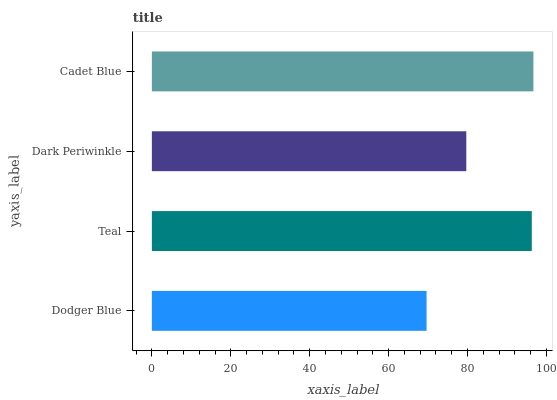Is Dodger Blue the minimum?
Answer yes or no. Yes. Is Cadet Blue the maximum?
Answer yes or no. Yes. Is Teal the minimum?
Answer yes or no. No. Is Teal the maximum?
Answer yes or no. No. Is Teal greater than Dodger Blue?
Answer yes or no. Yes. Is Dodger Blue less than Teal?
Answer yes or no. Yes. Is Dodger Blue greater than Teal?
Answer yes or no. No. Is Teal less than Dodger Blue?
Answer yes or no. No. Is Teal the high median?
Answer yes or no. Yes. Is Dark Periwinkle the low median?
Answer yes or no. Yes. Is Cadet Blue the high median?
Answer yes or no. No. Is Cadet Blue the low median?
Answer yes or no. No. 